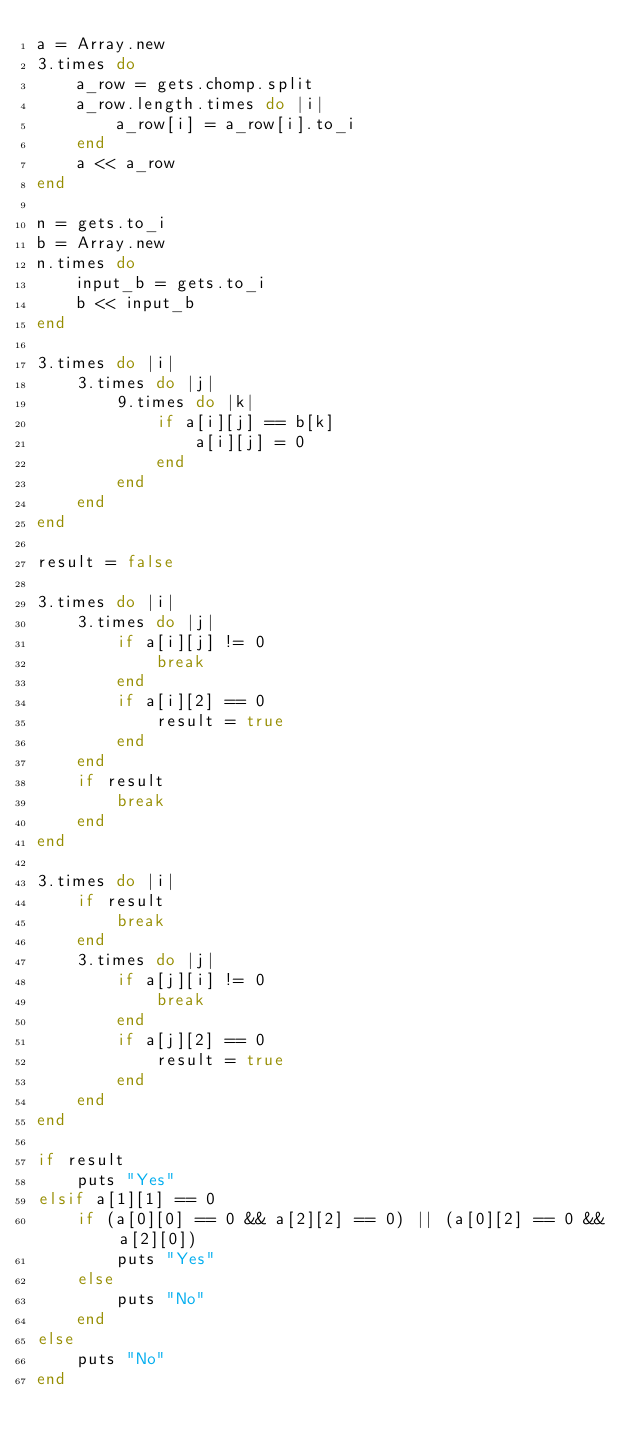Convert code to text. <code><loc_0><loc_0><loc_500><loc_500><_Ruby_>a = Array.new
3.times do
    a_row = gets.chomp.split
    a_row.length.times do |i|
        a_row[i] = a_row[i].to_i
    end
    a << a_row
end

n = gets.to_i
b = Array.new
n.times do
    input_b = gets.to_i
    b << input_b
end

3.times do |i|
    3.times do |j|
        9.times do |k|
            if a[i][j] == b[k]
                a[i][j] = 0
            end
        end
    end
end

result = false

3.times do |i|
    3.times do |j|
        if a[i][j] != 0
            break
        end
        if a[i][2] == 0
            result = true
        end
    end
    if result
        break
    end
end

3.times do |i|
    if result
        break
    end
    3.times do |j|
        if a[j][i] != 0
            break
        end
        if a[j][2] == 0
            result = true
        end
    end
end

if result
    puts "Yes"
elsif a[1][1] == 0
    if (a[0][0] == 0 && a[2][2] == 0) || (a[0][2] == 0 && a[2][0])
        puts "Yes"
    else
        puts "No"
    end
else
    puts "No"
end</code> 